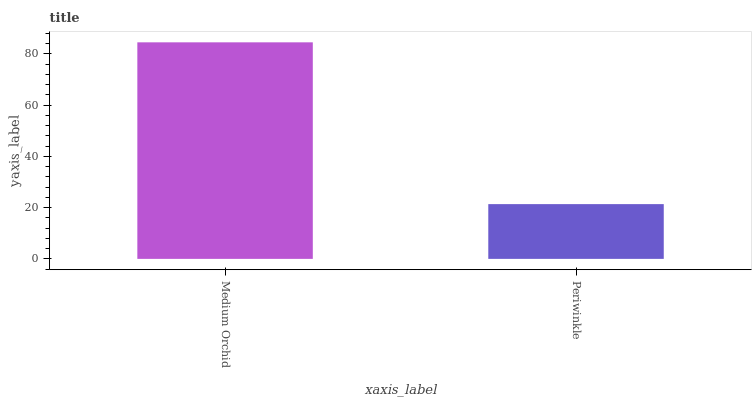Is Periwinkle the minimum?
Answer yes or no. Yes. Is Medium Orchid the maximum?
Answer yes or no. Yes. Is Periwinkle the maximum?
Answer yes or no. No. Is Medium Orchid greater than Periwinkle?
Answer yes or no. Yes. Is Periwinkle less than Medium Orchid?
Answer yes or no. Yes. Is Periwinkle greater than Medium Orchid?
Answer yes or no. No. Is Medium Orchid less than Periwinkle?
Answer yes or no. No. Is Medium Orchid the high median?
Answer yes or no. Yes. Is Periwinkle the low median?
Answer yes or no. Yes. Is Periwinkle the high median?
Answer yes or no. No. Is Medium Orchid the low median?
Answer yes or no. No. 